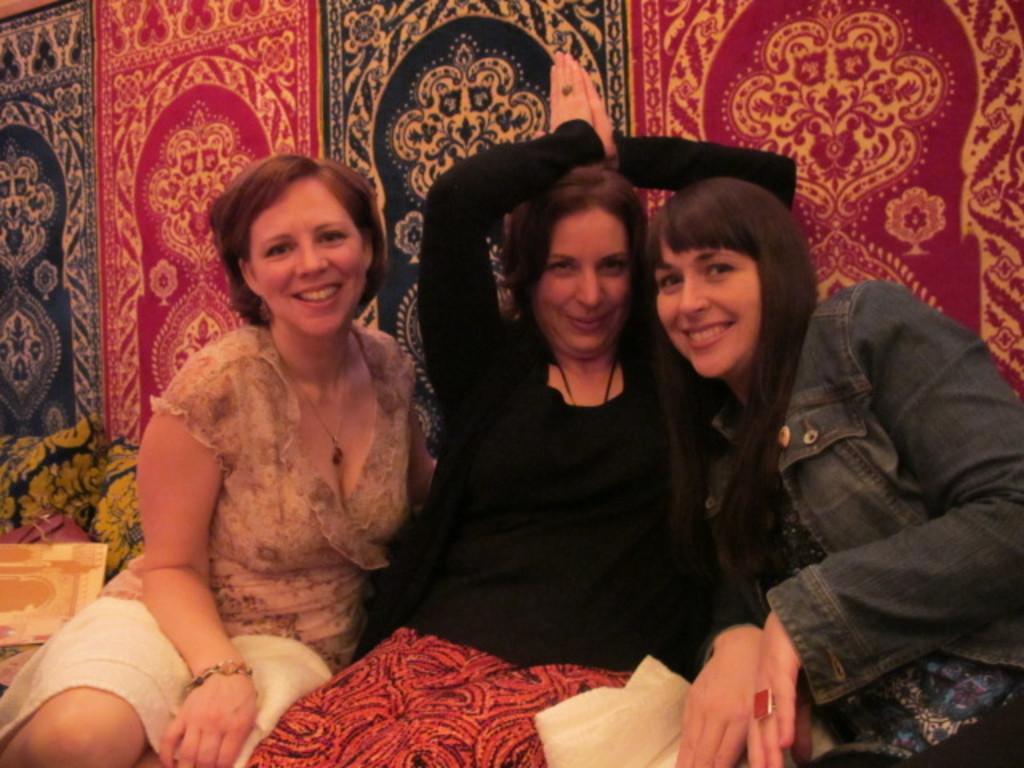Describe this image in one or two sentences. As we can see in the picture that three women are sitting and posing for the photo. The right side women wore a ring in her finger. The left side women wore bracelet in her hand and necklace, she is having a short hair and the right women is having long hair. 